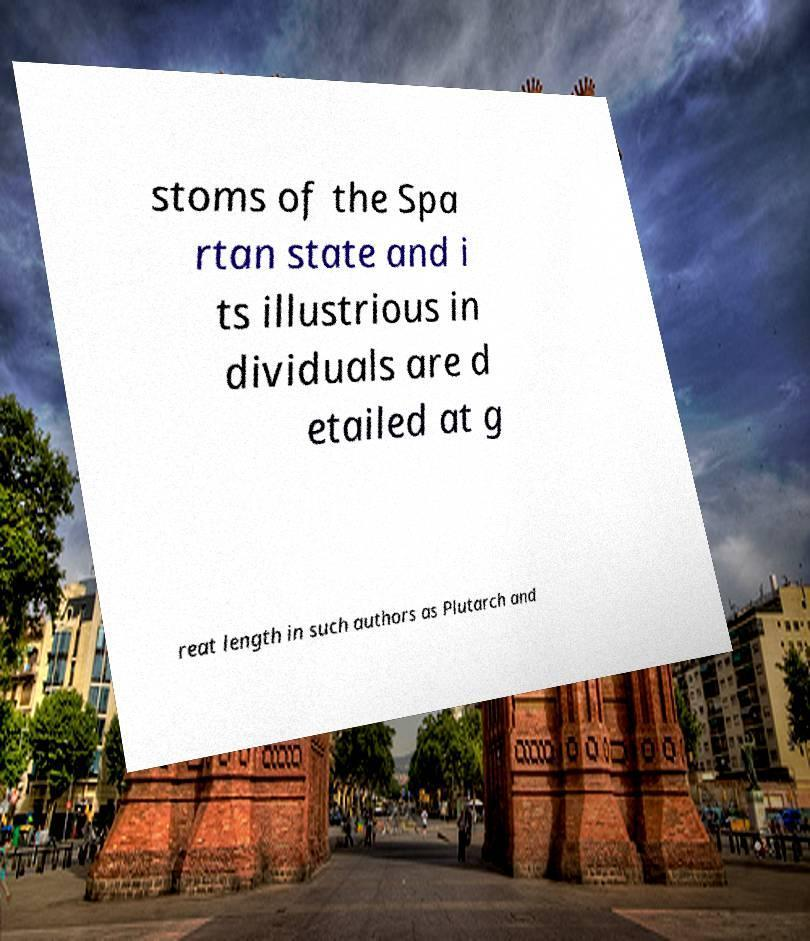Could you assist in decoding the text presented in this image and type it out clearly? stoms of the Spa rtan state and i ts illustrious in dividuals are d etailed at g reat length in such authors as Plutarch and 